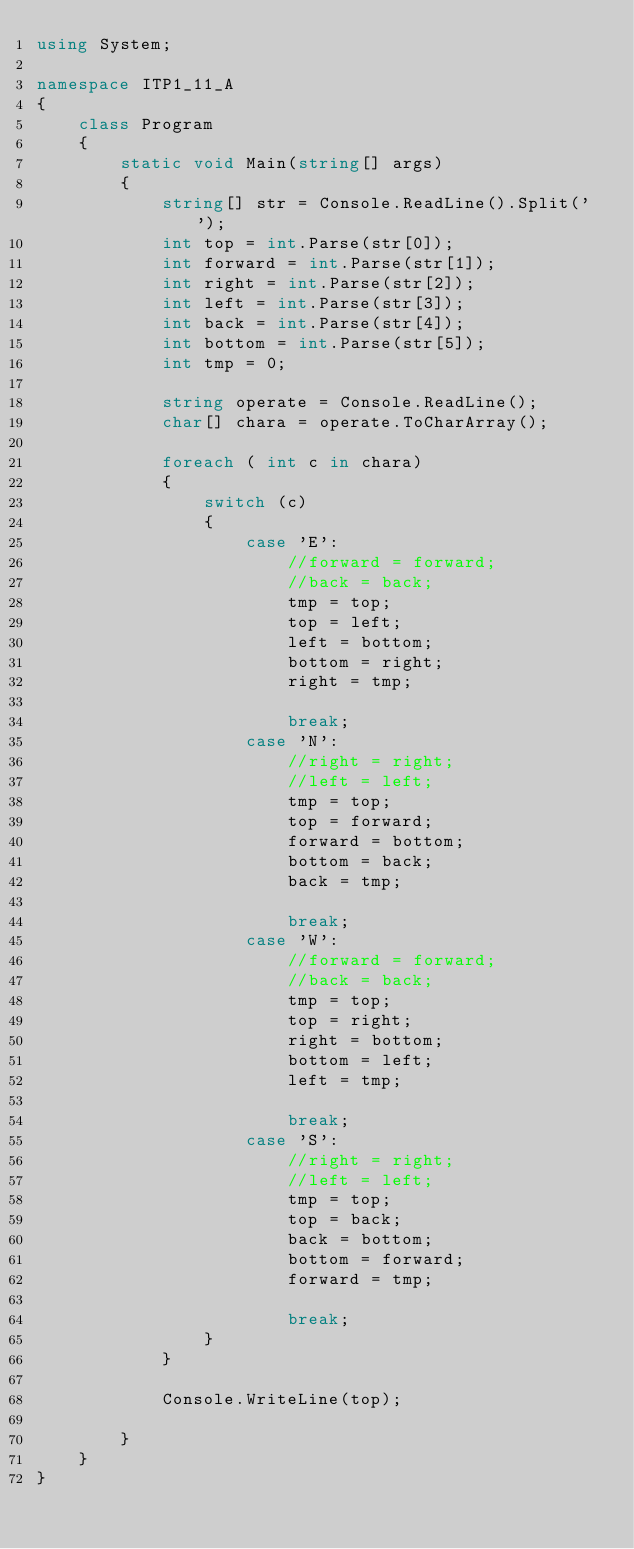<code> <loc_0><loc_0><loc_500><loc_500><_C#_>using System;

namespace ITP1_11_A
{
    class Program
    {
        static void Main(string[] args)
        {
            string[] str = Console.ReadLine().Split(' ');
            int top = int.Parse(str[0]);
            int forward = int.Parse(str[1]);
            int right = int.Parse(str[2]);
            int left = int.Parse(str[3]);
            int back = int.Parse(str[4]);
            int bottom = int.Parse(str[5]);
            int tmp = 0;

            string operate = Console.ReadLine();
            char[] chara = operate.ToCharArray();

            foreach ( int c in chara)
            {
                switch (c)
                {
                    case 'E':
                        //forward = forward;
                        //back = back;
                        tmp = top;
                        top = left;
                        left = bottom;
                        bottom = right;
                        right = tmp;

                        break;
                    case 'N':
                        //right = right;
                        //left = left;
                        tmp = top;
                        top = forward;
                        forward = bottom;
                        bottom = back;
                        back = tmp;

                        break;
                    case 'W':
                        //forward = forward;
                        //back = back;
                        tmp = top;
                        top = right;
                        right = bottom;
                        bottom = left;
                        left = tmp;

                        break;
                    case 'S':
                        //right = right;
                        //left = left;
                        tmp = top;
                        top = back;
                        back = bottom;
                        bottom = forward;
                        forward = tmp;

                        break;
                }
            }

            Console.WriteLine(top);

        }
    }
}</code> 